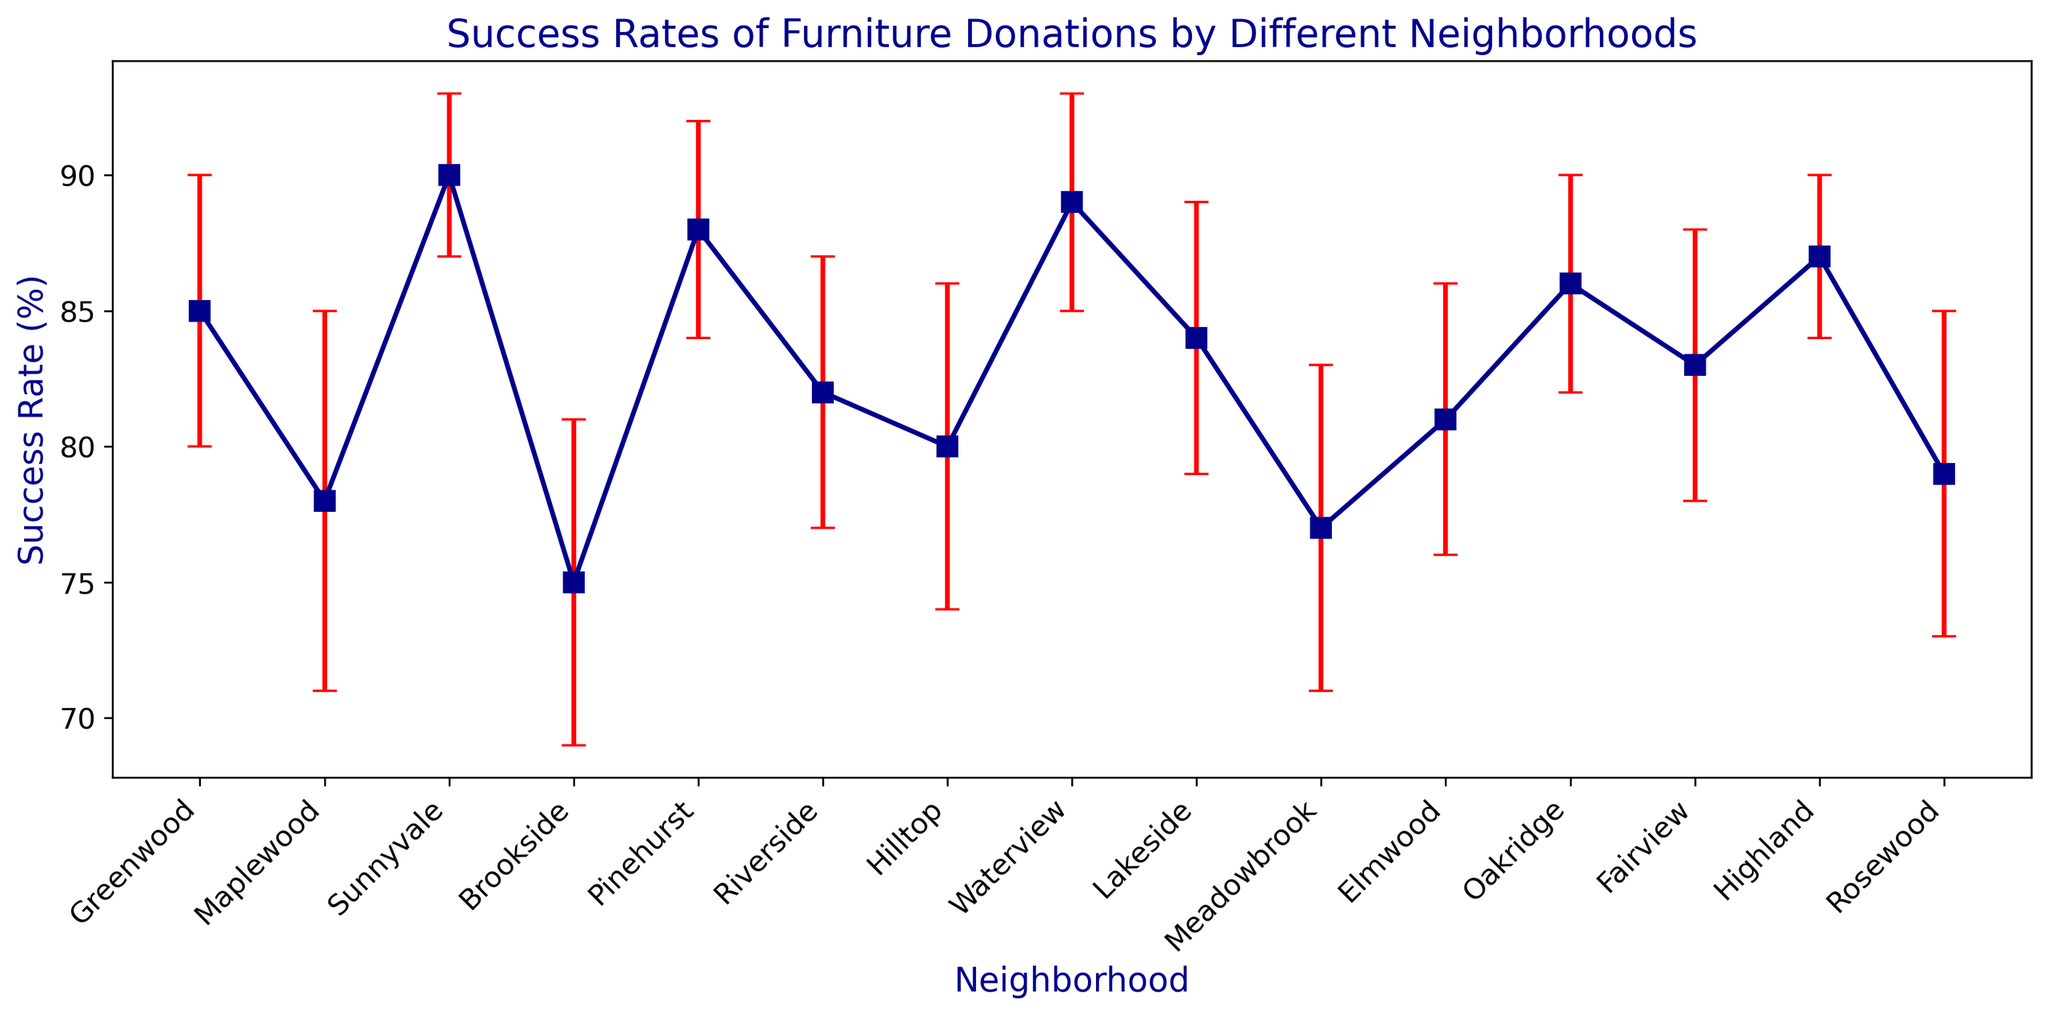What is the success rate of furniture donations for the neighborhood with the highest rate? In the plot, locate the neighborhood with the highest success rate value. Sunnyvale has the highest success rate at 90%.
Answer: 90% Which neighborhood has the lowest success rate in furniture donations? Identify the neighborhood with the shortest graphical mark in terms of the average value of success rate. Brookside has the lowest success rate at 75%.
Answer: Brookside What is the average success rate of Hilltop and Rosewood combined? Sum the success rates of Hilltop (80%) and Rosewood (79%) and then divide by 2. (80 + 79) / 2 = 79.5
Answer: 79.5 Which neighborhood has the largest uncertainty in its success rate? Identify the neighborhood with the longest error bar. Maplewood has the largest standard deviation of 7%, indicating the highest uncertainty.
Answer: Maplewood How many neighborhoods have a success rate above 85%? Count the number of neighborhoods where the success rate markers lie above the 85% mark on the y-axis. There are 6 neighborhoods: Greenwood, Sunnyvale, Pinehurst, Waterview, Oakridge, and Highland.
Answer: 6 Compare the success rates of Elmwood and Pinehurst. Which is higher and by how much? Elmwood has an 81% success rate, and Pinehurst has an 88% success rate. The difference is 88% - 81% = 7%. Pinehurst's success rate is 7% higher than Elmwood's.
Answer: Pinehurst by 7% Which neighborhoods have a standard deviation of 5%? Identify from the error bars which neighborhoods have error bars representing a 5% standard deviation: Greenwood, Riverside, Lakeside, Elmwood, and Fairview.
Answer: Greenwood, Riverside, Lakeside, Elmwood, Fairview Is Highland's success rate closer to Sunnyvale's or Brookside's? Compare Highland's success rate (87%) with Sunnyvale's (90%) and Brookside's (75%). The differences are 90 - 87 = 3% and 87 - 75 = 12%, so Highland is closer to Sunnyvale.
Answer: Sunnyvale What is the total sum of the success rates for all neighborhoods exceeding 85%? Sum the success rates of all neighborhoods above 85%: Sunnyvale (90), Pinehurst (88), Waterview (89), Oakridge (86), Highland (87). 90 + 88 + 89 + 86 + 87 = 440.
Answer: 440 If we consider a neighborhood with a success rate of 80% and above to be successful, how many successful neighborhoods are there? Count the number of neighborhoods with success rates of 80% or more: Greenwood, Sunnyvale, Pinehurst, Riverside, Hilltop, Waterview, Lakeside, Elmwood, Oakridge, Fairview, Highland. There are 11 such neighborhoods.
Answer: 11 